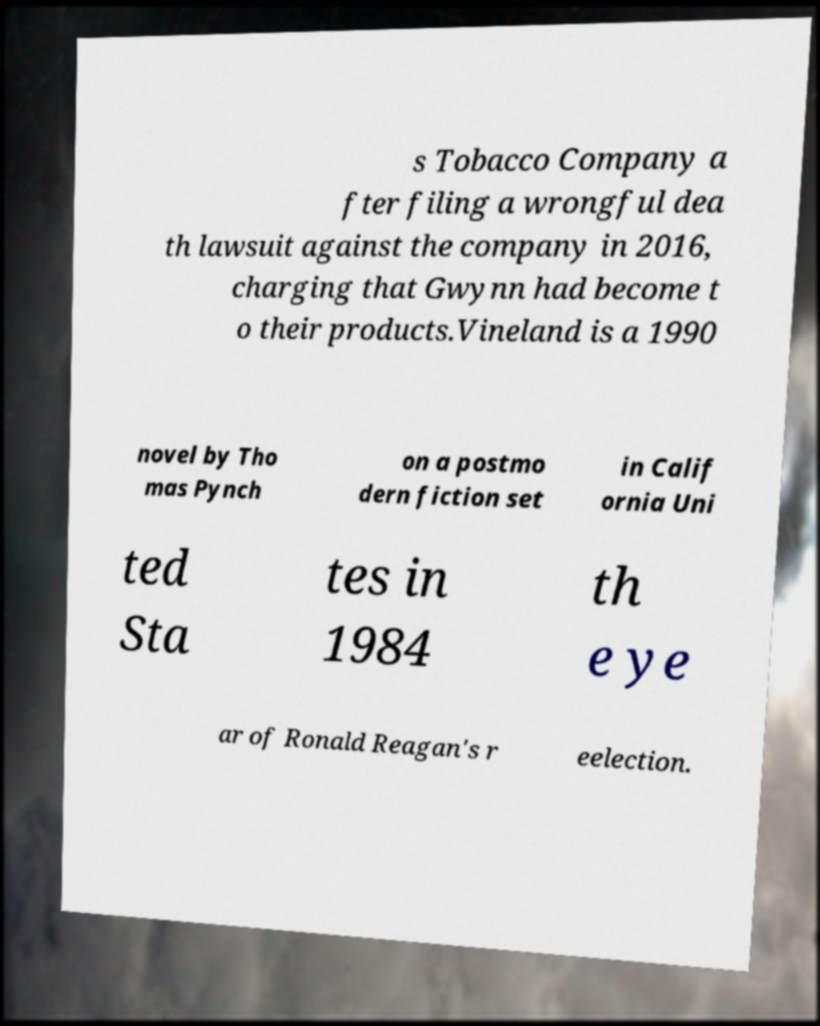Can you accurately transcribe the text from the provided image for me? s Tobacco Company a fter filing a wrongful dea th lawsuit against the company in 2016, charging that Gwynn had become t o their products.Vineland is a 1990 novel by Tho mas Pynch on a postmo dern fiction set in Calif ornia Uni ted Sta tes in 1984 th e ye ar of Ronald Reagan's r eelection. 